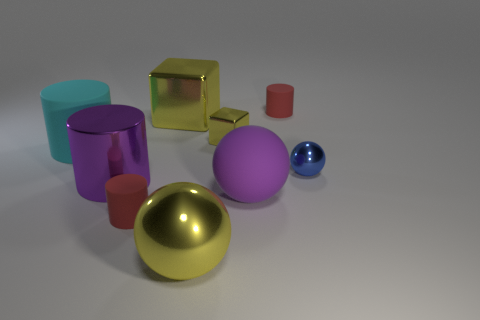Do the object that is to the left of the purple metal cylinder and the large purple cylinder have the same size?
Keep it short and to the point. Yes. Are there fewer large purple rubber objects than red cylinders?
Your answer should be very brief. Yes. There is a tiny metal object that is the same color as the large block; what shape is it?
Ensure brevity in your answer.  Cube. How many big yellow objects are on the right side of the large block?
Your response must be concise. 1. Does the blue metallic thing have the same shape as the purple matte object?
Ensure brevity in your answer.  Yes. What number of rubber objects are to the left of the small shiny block and behind the small metallic ball?
Provide a succinct answer. 1. How many things are tiny shiny spheres or small things behind the big yellow block?
Provide a succinct answer. 2. Are there more purple shiny cylinders than small blue cylinders?
Give a very brief answer. Yes. There is a shiny thing behind the tiny yellow metal thing; what shape is it?
Ensure brevity in your answer.  Cube. How many other things have the same shape as the large cyan thing?
Give a very brief answer. 3. 